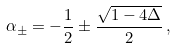<formula> <loc_0><loc_0><loc_500><loc_500>\alpha _ { \pm } = - \frac { 1 } { 2 } \pm \frac { \sqrt { 1 - 4 \Delta } } { 2 } \, ,</formula> 